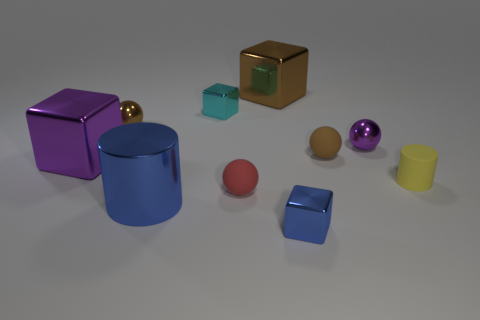Does the brown object that is to the left of the big blue cylinder have the same material as the big object in front of the yellow thing?
Your answer should be very brief. Yes. How many things are either metal objects that are on the right side of the large blue object or small brown objects?
Provide a short and direct response. 6. Is the number of brown balls in front of the purple metallic cube less than the number of small red objects to the right of the large brown shiny object?
Your answer should be compact. No. What number of other objects are the same size as the cyan cube?
Give a very brief answer. 6. Do the large blue cylinder and the small brown sphere left of the blue block have the same material?
Keep it short and to the point. Yes. How many things are either small metal balls that are left of the tiny blue thing or small balls that are behind the tiny purple ball?
Keep it short and to the point. 1. The small cylinder is what color?
Keep it short and to the point. Yellow. Are there fewer big blue metal things behind the small red rubber ball than tiny green shiny blocks?
Your response must be concise. No. Is there anything else that has the same shape as the small brown metallic thing?
Give a very brief answer. Yes. Are there any big red matte things?
Provide a short and direct response. No. 